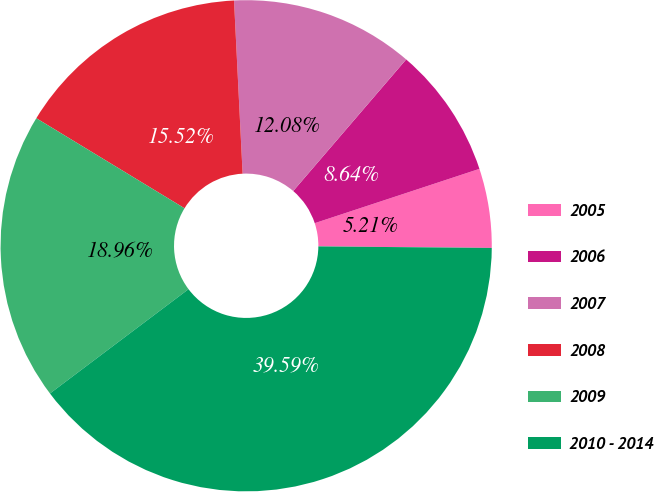Convert chart to OTSL. <chart><loc_0><loc_0><loc_500><loc_500><pie_chart><fcel>2005<fcel>2006<fcel>2007<fcel>2008<fcel>2009<fcel>2010 - 2014<nl><fcel>5.21%<fcel>8.64%<fcel>12.08%<fcel>15.52%<fcel>18.96%<fcel>39.59%<nl></chart> 